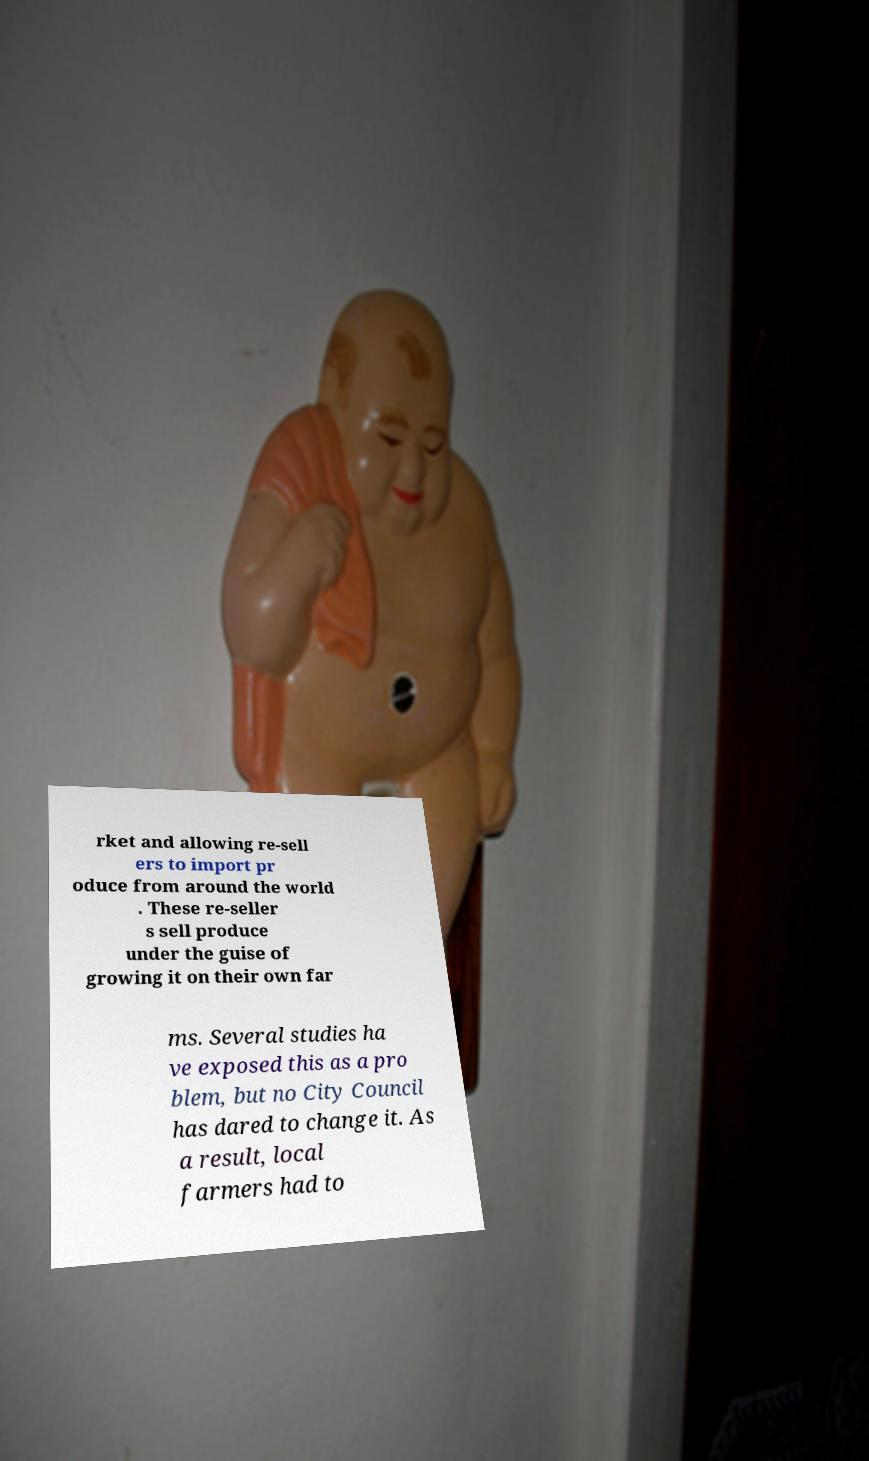Could you extract and type out the text from this image? rket and allowing re-sell ers to import pr oduce from around the world . These re-seller s sell produce under the guise of growing it on their own far ms. Several studies ha ve exposed this as a pro blem, but no City Council has dared to change it. As a result, local farmers had to 